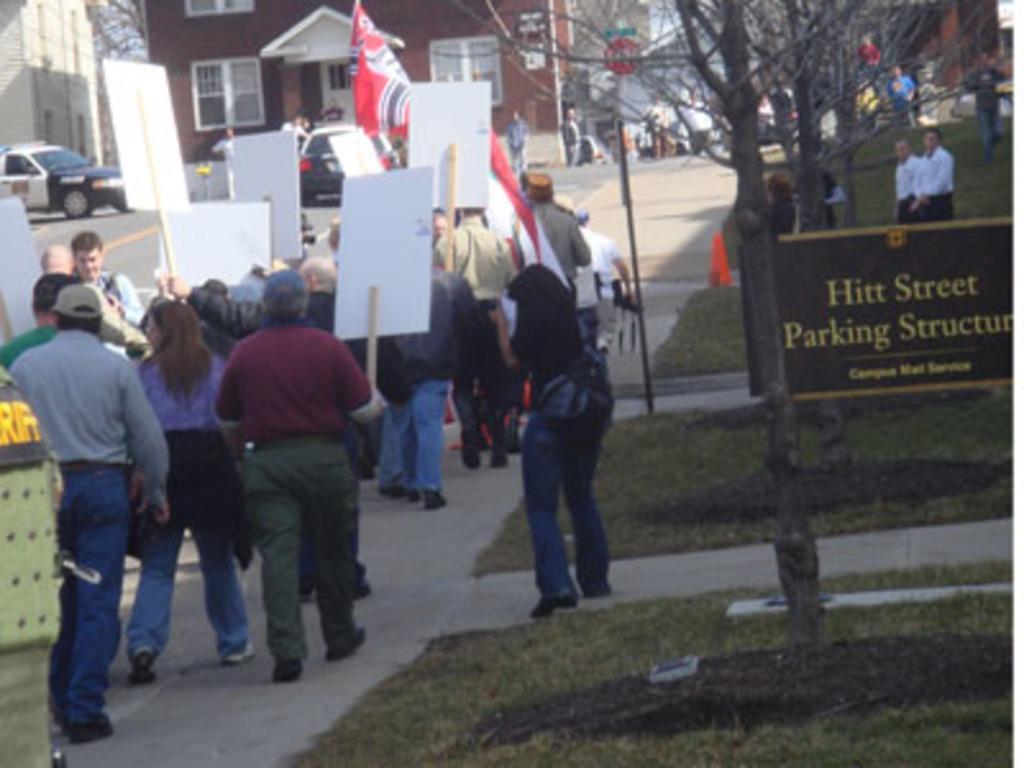Could you give a brief overview of what you see in this image? In this picture, it seems like a notice board on the grassland in the foreground, there are people holding posters in their hands, trees, houses and vehicles in the background. 